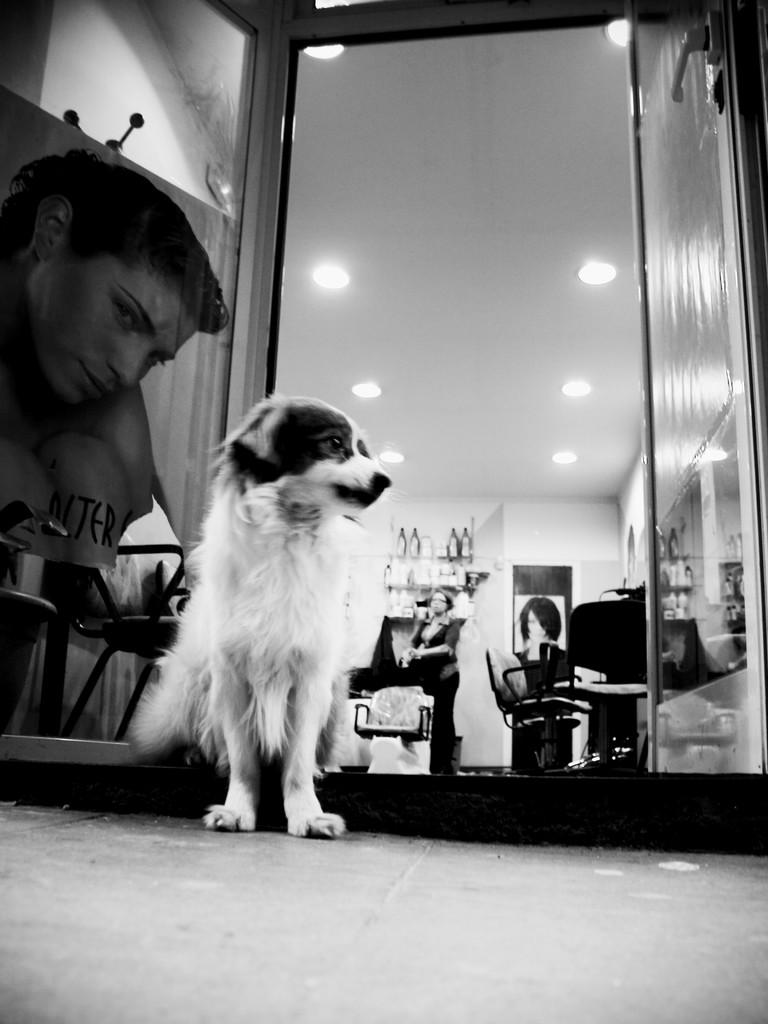What type of animal is in the image? There is a dog in the image. Who else is present in the image? There is a woman in the image. What is the woman doing in the image? The woman is standing on the back of the dog. What else can be seen in the image? There is a photo in the image. What type of protest is happening in the image? There is no protest present in the image. What type of sofa is the woman sitting on in the image? There is no sofa present in the image; the woman is standing on the back of the dog. 